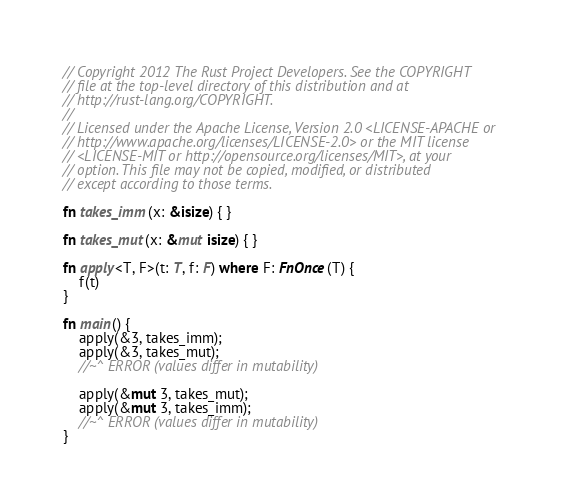<code> <loc_0><loc_0><loc_500><loc_500><_Rust_>// Copyright 2012 The Rust Project Developers. See the COPYRIGHT
// file at the top-level directory of this distribution and at
// http://rust-lang.org/COPYRIGHT.
//
// Licensed under the Apache License, Version 2.0 <LICENSE-APACHE or
// http://www.apache.org/licenses/LICENSE-2.0> or the MIT license
// <LICENSE-MIT or http://opensource.org/licenses/MIT>, at your
// option. This file may not be copied, modified, or distributed
// except according to those terms.

fn takes_imm(x: &isize) { }

fn takes_mut(x: &mut isize) { }

fn apply<T, F>(t: T, f: F) where F: FnOnce(T) {
    f(t)
}

fn main() {
    apply(&3, takes_imm);
    apply(&3, takes_mut);
    //~^ ERROR (values differ in mutability)

    apply(&mut 3, takes_mut);
    apply(&mut 3, takes_imm);
    //~^ ERROR (values differ in mutability)
}
</code> 